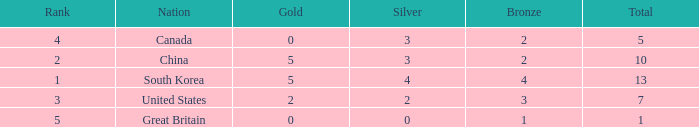What is the lowest Rank, when Nation is Great Britain, and when Bronze is less than 1? None. 